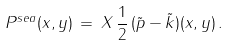Convert formula to latex. <formula><loc_0><loc_0><loc_500><loc_500>P ^ { s e a } ( x , y ) \, = \, X \, \frac { 1 } { 2 } \, ( \tilde { p } - \tilde { k } ) ( x , y ) \, .</formula> 